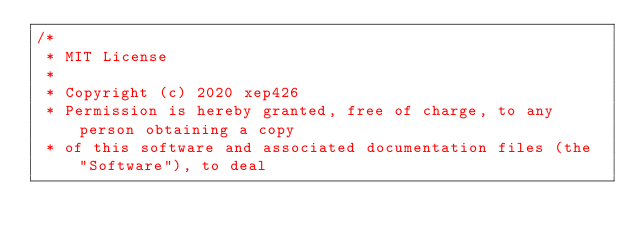Convert code to text. <code><loc_0><loc_0><loc_500><loc_500><_Kotlin_>/*
 * MIT License
 *
 * Copyright (c) 2020 xep426
 * Permission is hereby granted, free of charge, to any person obtaining a copy
 * of this software and associated documentation files (the "Software"), to deal</code> 